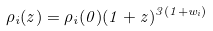Convert formula to latex. <formula><loc_0><loc_0><loc_500><loc_500>\rho _ { i } ( z ) = \rho _ { i } ( 0 ) ( 1 + z ) ^ { 3 ( 1 + w _ { i } ) }</formula> 